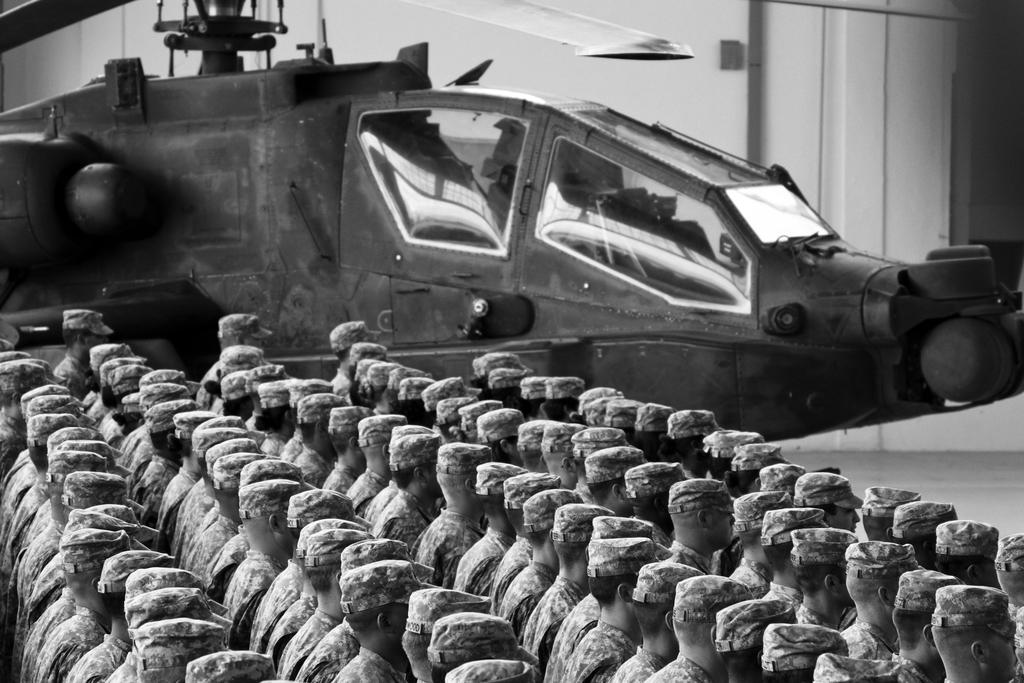What is the color scheme of the image? The image is black and white. What can be seen in the image? There are persons in the image. What is visible in the background of the image? There is a helicopter and other objects in the background of the image. How much sugar is being used by the persons in the image? There is no indication of sugar usage in the image, as it is black and white and focuses on persons and a helicopter in the background. What type of nose can be seen on the helicopter in the image? The image is black and white and does not provide enough detail to determine the type of nose on the helicopter. 